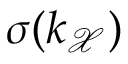Convert formula to latex. <formula><loc_0><loc_0><loc_500><loc_500>\sigma ( k _ { \mathcal { X } } )</formula> 